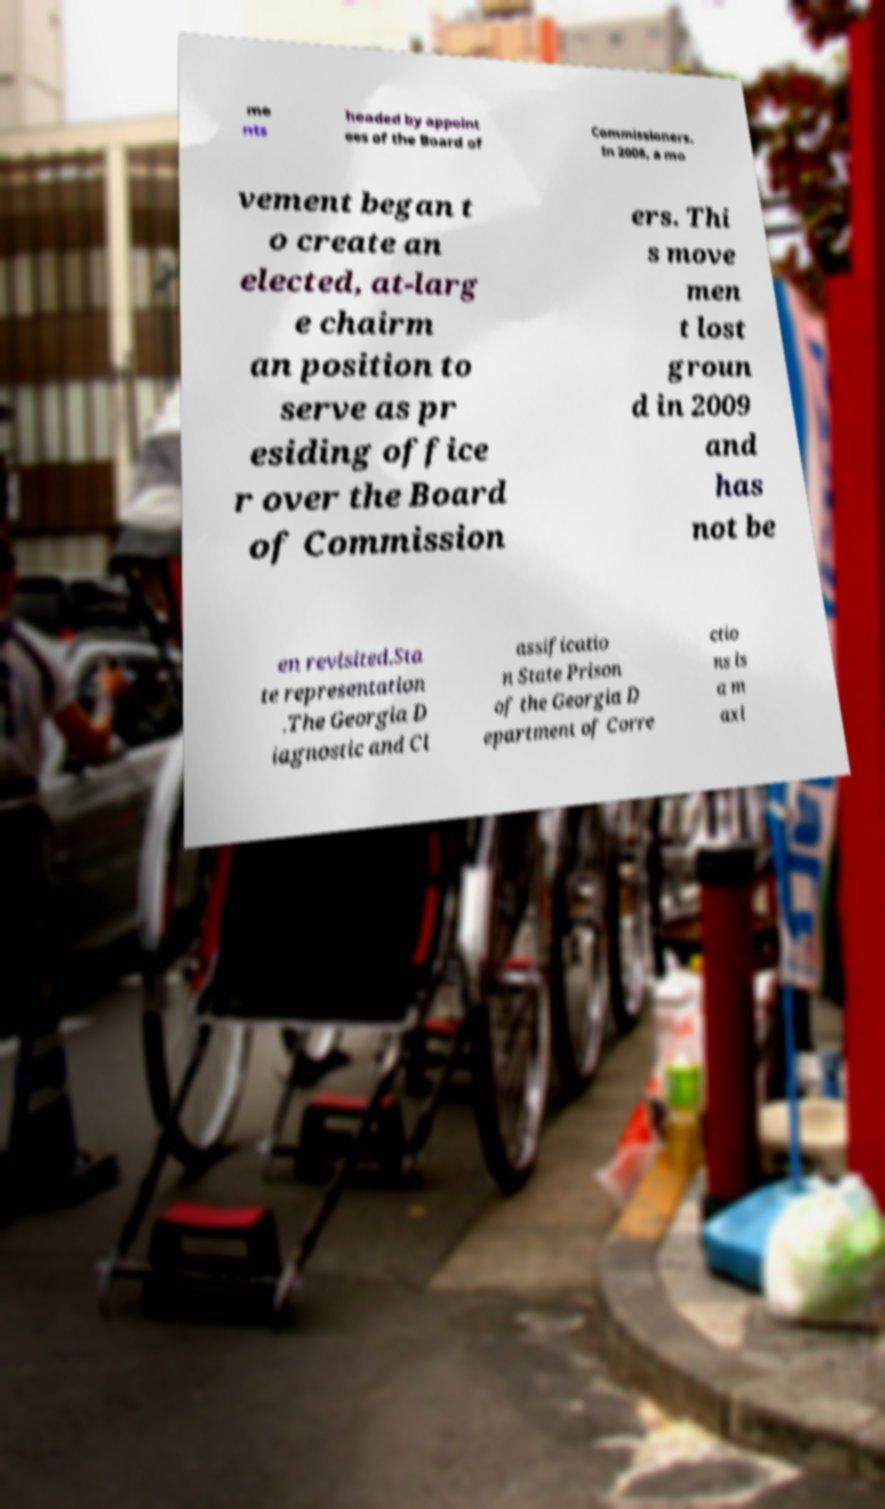Can you read and provide the text displayed in the image?This photo seems to have some interesting text. Can you extract and type it out for me? me nts headed by appoint ees of the Board of Commissioners. In 2008, a mo vement began t o create an elected, at-larg e chairm an position to serve as pr esiding office r over the Board of Commission ers. Thi s move men t lost groun d in 2009 and has not be en revisited.Sta te representation .The Georgia D iagnostic and Cl assificatio n State Prison of the Georgia D epartment of Corre ctio ns is a m axi 